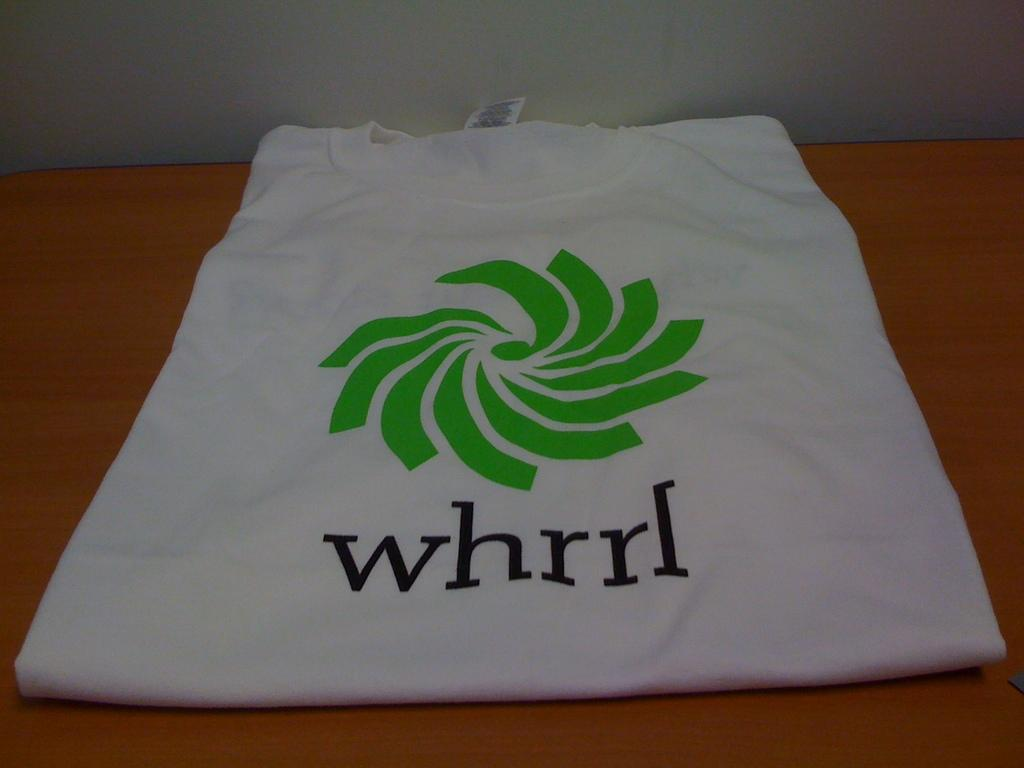What type of clothing item is visible in the image? There is a white t-shirt in the image. Where is the t-shirt located? The t-shirt is placed on a table. Is there a river flowing through the t-shirt in the image? No, there is no river present in the image, and the t-shirt is not depicted as having a river flowing through it. 